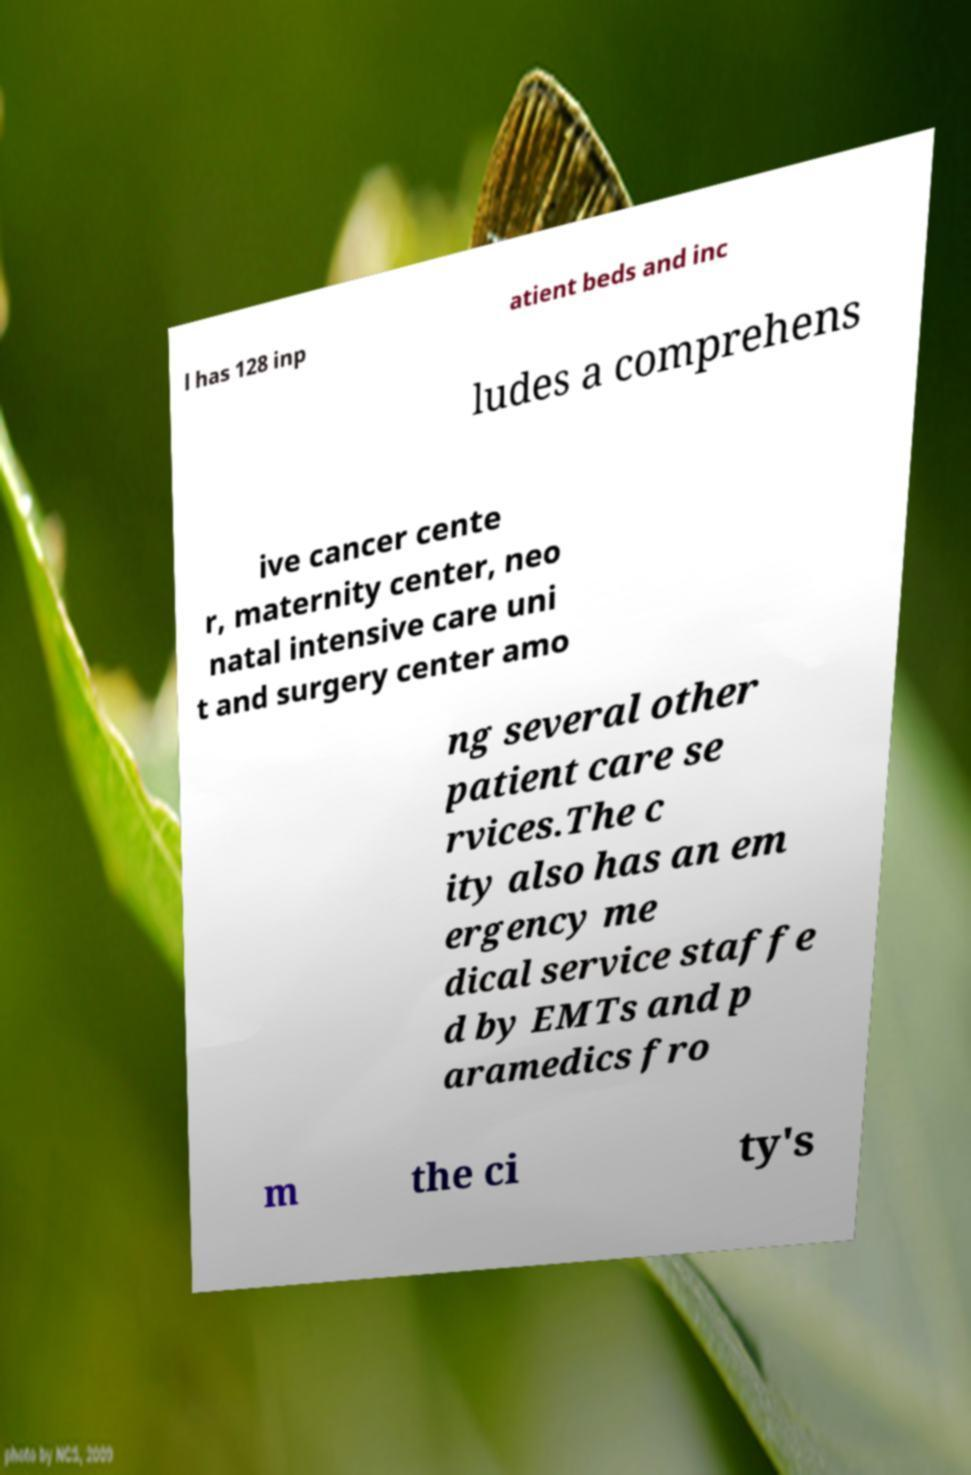I need the written content from this picture converted into text. Can you do that? l has 128 inp atient beds and inc ludes a comprehens ive cancer cente r, maternity center, neo natal intensive care uni t and surgery center amo ng several other patient care se rvices.The c ity also has an em ergency me dical service staffe d by EMTs and p aramedics fro m the ci ty's 